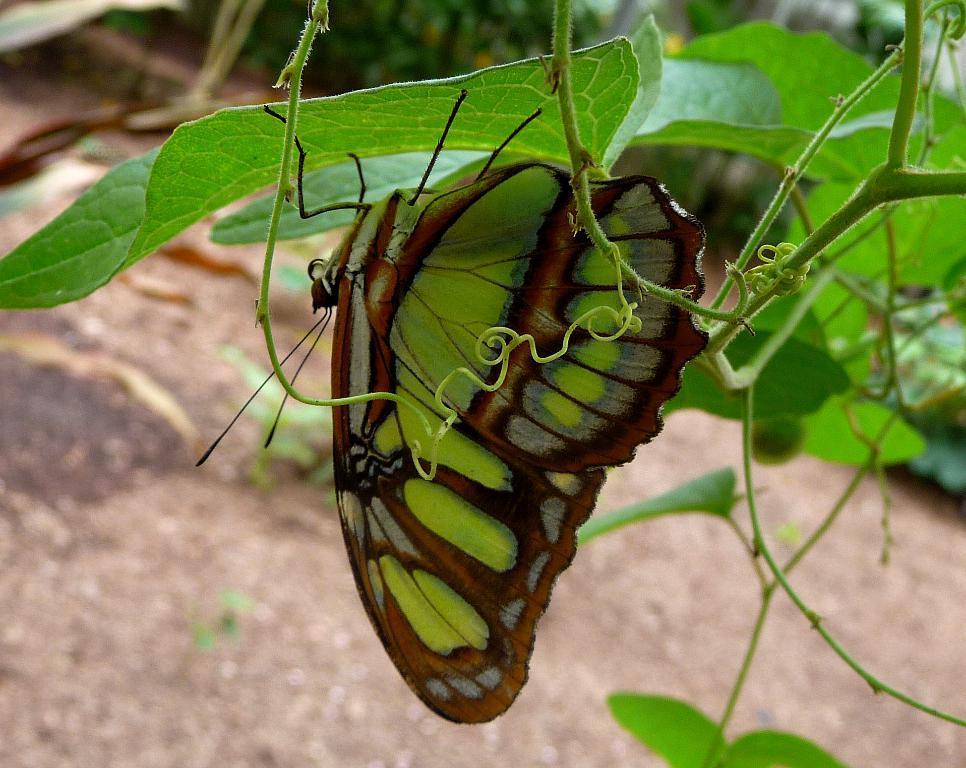In one or two sentences, can you explain what this image depicts? This image consists of a butterfly on a leaf. At the bottom, there is ground. 